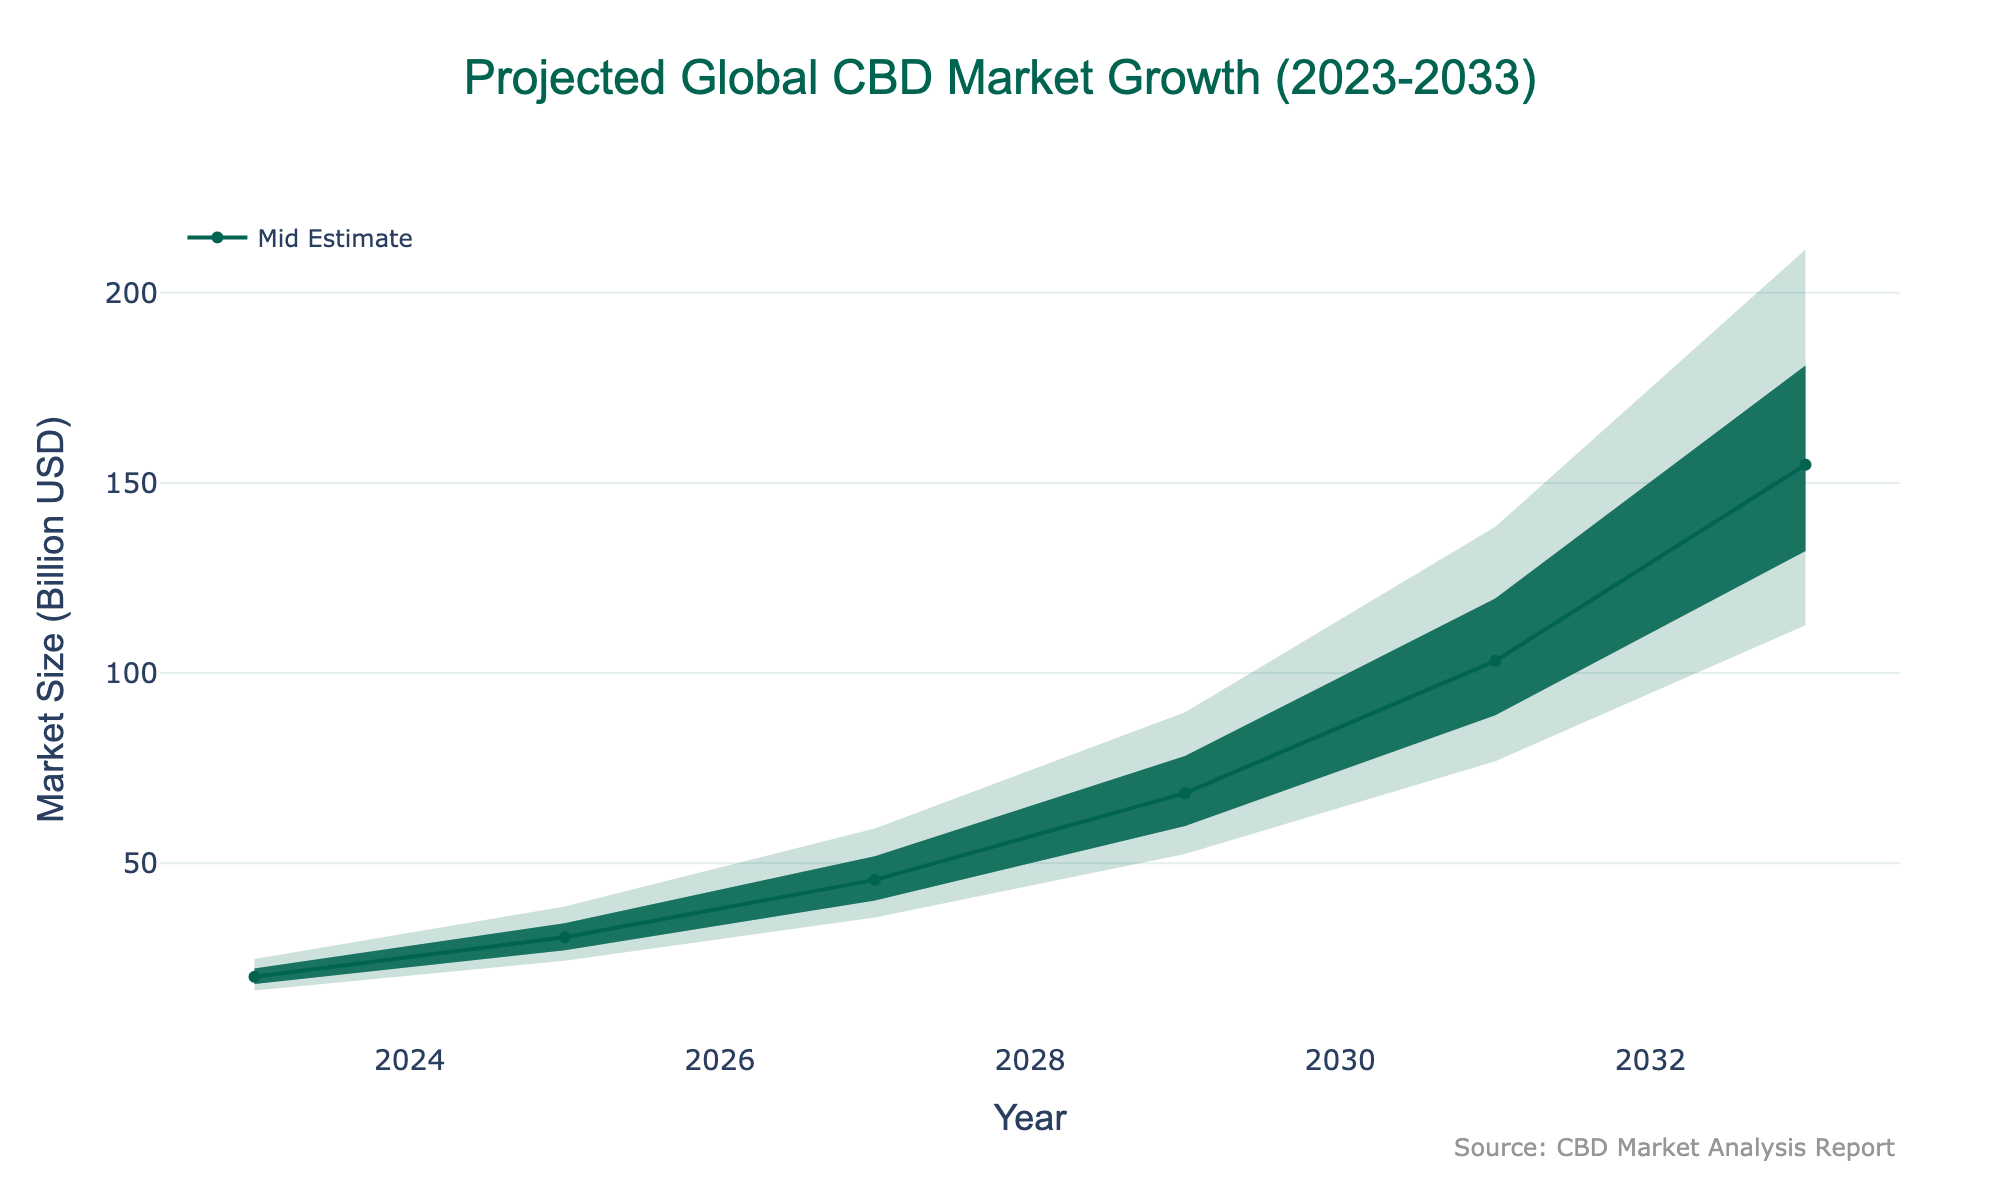what is the title of the chart? The title is located at the top of the chart and provides an overview of the chart's main focus.
Answer: Projected Global CBD Market Growth (2023-2033) What is the mid estimate of the market size in 2025? Look at the 'Mid Estimate' line for the year 2025; it's where the 2025 label intersects with this estimate curve.
Answer: 30.5 billion USD Which product type is projected to have the largest share in 2033? Check the breakdown of product types for the year 2033 and identify the highest percentage value.
Answer: Tinctures How much does the mid estimate increase from 2023 to 2029? Subtract the mid estimate of 2023 from the mid estimate of 2029: 68.4 billion USD - 20.1 billion USD.
Answer: 48.3 billion USD What's the range between low and high estimates in 2033? Subtract the low estimate from the high estimate for the year 2033: 211.4 billion USD - 112.6 billion USD.
Answer: 98.8 billion USD Between which years is the mid estimate of market size expected to see the largest growth? Calculate the differences between consecutive years' mid estimates and find the maximum: (30.5-20.1), (45.6-30.5), (68.4-45.6), (103.2-68.4), (154.8-103.2).
Answer: Between 2029 and 2031 Which estimates are depicted in the lighter shades? Look at the lighter shades on the chart, they represent the areas between the lower estimates.
Answer: Low to Low-Mid Estimates What is the trend for the share of tinctures from 2023 to 2033? Observe the percentage values for tinctures from 2023 to 2033 and describe their change over time.
Answer: Decreasing How much is the high estimate projected to increase from 2027 to 2031? Subtract the high estimate in 2027 from the high estimate in 2031: 138.5 billion USD - 59.1 billion USD.
Answer: 79.4 billion USD 